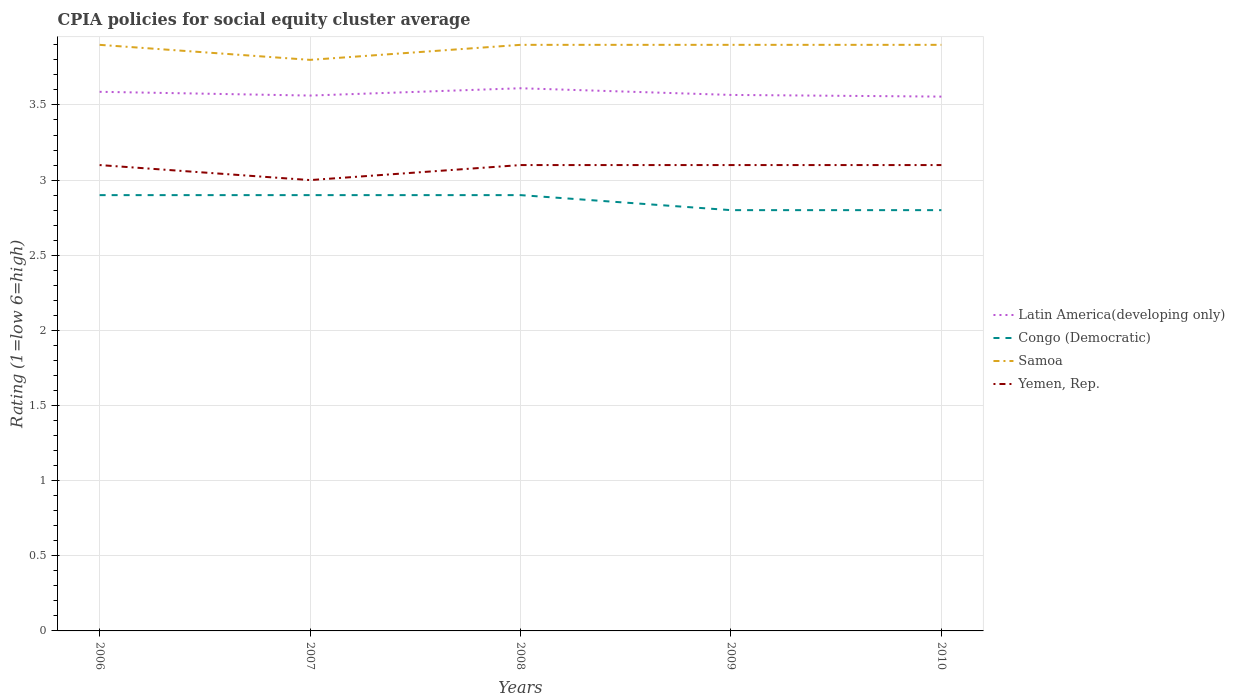How many different coloured lines are there?
Offer a terse response. 4. Does the line corresponding to Yemen, Rep. intersect with the line corresponding to Latin America(developing only)?
Provide a succinct answer. No. What is the total CPIA rating in Latin America(developing only) in the graph?
Ensure brevity in your answer.  -0.02. What is the difference between the highest and the second highest CPIA rating in Congo (Democratic)?
Provide a short and direct response. 0.1. What is the difference between the highest and the lowest CPIA rating in Latin America(developing only)?
Keep it short and to the point. 2. How many lines are there?
Offer a very short reply. 4. How many years are there in the graph?
Make the answer very short. 5. Are the values on the major ticks of Y-axis written in scientific E-notation?
Your answer should be very brief. No. Where does the legend appear in the graph?
Ensure brevity in your answer.  Center right. How are the legend labels stacked?
Keep it short and to the point. Vertical. What is the title of the graph?
Make the answer very short. CPIA policies for social equity cluster average. Does "Georgia" appear as one of the legend labels in the graph?
Your answer should be compact. No. What is the label or title of the X-axis?
Offer a very short reply. Years. What is the Rating (1=low 6=high) of Latin America(developing only) in 2006?
Provide a succinct answer. 3.59. What is the Rating (1=low 6=high) of Congo (Democratic) in 2006?
Provide a short and direct response. 2.9. What is the Rating (1=low 6=high) in Samoa in 2006?
Keep it short and to the point. 3.9. What is the Rating (1=low 6=high) of Yemen, Rep. in 2006?
Your answer should be very brief. 3.1. What is the Rating (1=low 6=high) of Latin America(developing only) in 2007?
Provide a short and direct response. 3.56. What is the Rating (1=low 6=high) of Congo (Democratic) in 2007?
Your answer should be compact. 2.9. What is the Rating (1=low 6=high) in Yemen, Rep. in 2007?
Your answer should be compact. 3. What is the Rating (1=low 6=high) of Latin America(developing only) in 2008?
Your answer should be very brief. 3.61. What is the Rating (1=low 6=high) in Latin America(developing only) in 2009?
Give a very brief answer. 3.57. What is the Rating (1=low 6=high) in Congo (Democratic) in 2009?
Give a very brief answer. 2.8. What is the Rating (1=low 6=high) in Yemen, Rep. in 2009?
Keep it short and to the point. 3.1. What is the Rating (1=low 6=high) of Latin America(developing only) in 2010?
Offer a very short reply. 3.56. What is the Rating (1=low 6=high) in Congo (Democratic) in 2010?
Give a very brief answer. 2.8. What is the Rating (1=low 6=high) in Samoa in 2010?
Your answer should be very brief. 3.9. Across all years, what is the maximum Rating (1=low 6=high) of Latin America(developing only)?
Provide a short and direct response. 3.61. Across all years, what is the maximum Rating (1=low 6=high) of Yemen, Rep.?
Your answer should be compact. 3.1. Across all years, what is the minimum Rating (1=low 6=high) in Latin America(developing only)?
Offer a very short reply. 3.56. Across all years, what is the minimum Rating (1=low 6=high) in Congo (Democratic)?
Your response must be concise. 2.8. Across all years, what is the minimum Rating (1=low 6=high) in Samoa?
Provide a short and direct response. 3.8. What is the total Rating (1=low 6=high) of Latin America(developing only) in the graph?
Make the answer very short. 17.88. What is the total Rating (1=low 6=high) of Congo (Democratic) in the graph?
Your answer should be compact. 14.3. What is the total Rating (1=low 6=high) in Samoa in the graph?
Provide a succinct answer. 19.4. What is the difference between the Rating (1=low 6=high) of Latin America(developing only) in 2006 and that in 2007?
Offer a very short reply. 0.03. What is the difference between the Rating (1=low 6=high) of Yemen, Rep. in 2006 and that in 2007?
Offer a terse response. 0.1. What is the difference between the Rating (1=low 6=high) in Latin America(developing only) in 2006 and that in 2008?
Your answer should be very brief. -0.02. What is the difference between the Rating (1=low 6=high) in Congo (Democratic) in 2006 and that in 2008?
Keep it short and to the point. 0. What is the difference between the Rating (1=low 6=high) in Samoa in 2006 and that in 2008?
Your response must be concise. 0. What is the difference between the Rating (1=low 6=high) in Yemen, Rep. in 2006 and that in 2008?
Ensure brevity in your answer.  0. What is the difference between the Rating (1=low 6=high) of Latin America(developing only) in 2006 and that in 2009?
Your answer should be very brief. 0.02. What is the difference between the Rating (1=low 6=high) in Latin America(developing only) in 2006 and that in 2010?
Make the answer very short. 0.03. What is the difference between the Rating (1=low 6=high) in Congo (Democratic) in 2006 and that in 2010?
Offer a very short reply. 0.1. What is the difference between the Rating (1=low 6=high) in Yemen, Rep. in 2006 and that in 2010?
Your answer should be very brief. 0. What is the difference between the Rating (1=low 6=high) of Latin America(developing only) in 2007 and that in 2008?
Provide a succinct answer. -0.05. What is the difference between the Rating (1=low 6=high) in Yemen, Rep. in 2007 and that in 2008?
Keep it short and to the point. -0.1. What is the difference between the Rating (1=low 6=high) in Latin America(developing only) in 2007 and that in 2009?
Offer a terse response. -0. What is the difference between the Rating (1=low 6=high) in Yemen, Rep. in 2007 and that in 2009?
Make the answer very short. -0.1. What is the difference between the Rating (1=low 6=high) of Latin America(developing only) in 2007 and that in 2010?
Provide a short and direct response. 0.01. What is the difference between the Rating (1=low 6=high) in Congo (Democratic) in 2007 and that in 2010?
Make the answer very short. 0.1. What is the difference between the Rating (1=low 6=high) in Latin America(developing only) in 2008 and that in 2009?
Make the answer very short. 0.04. What is the difference between the Rating (1=low 6=high) in Samoa in 2008 and that in 2009?
Provide a succinct answer. 0. What is the difference between the Rating (1=low 6=high) in Yemen, Rep. in 2008 and that in 2009?
Keep it short and to the point. 0. What is the difference between the Rating (1=low 6=high) in Latin America(developing only) in 2008 and that in 2010?
Keep it short and to the point. 0.06. What is the difference between the Rating (1=low 6=high) of Congo (Democratic) in 2008 and that in 2010?
Your answer should be very brief. 0.1. What is the difference between the Rating (1=low 6=high) of Yemen, Rep. in 2008 and that in 2010?
Offer a very short reply. 0. What is the difference between the Rating (1=low 6=high) of Latin America(developing only) in 2009 and that in 2010?
Offer a terse response. 0.01. What is the difference between the Rating (1=low 6=high) in Latin America(developing only) in 2006 and the Rating (1=low 6=high) in Congo (Democratic) in 2007?
Your response must be concise. 0.69. What is the difference between the Rating (1=low 6=high) in Latin America(developing only) in 2006 and the Rating (1=low 6=high) in Samoa in 2007?
Your answer should be very brief. -0.21. What is the difference between the Rating (1=low 6=high) in Latin America(developing only) in 2006 and the Rating (1=low 6=high) in Yemen, Rep. in 2007?
Make the answer very short. 0.59. What is the difference between the Rating (1=low 6=high) of Congo (Democratic) in 2006 and the Rating (1=low 6=high) of Samoa in 2007?
Provide a short and direct response. -0.9. What is the difference between the Rating (1=low 6=high) of Latin America(developing only) in 2006 and the Rating (1=low 6=high) of Congo (Democratic) in 2008?
Provide a short and direct response. 0.69. What is the difference between the Rating (1=low 6=high) of Latin America(developing only) in 2006 and the Rating (1=low 6=high) of Samoa in 2008?
Provide a succinct answer. -0.31. What is the difference between the Rating (1=low 6=high) of Latin America(developing only) in 2006 and the Rating (1=low 6=high) of Yemen, Rep. in 2008?
Ensure brevity in your answer.  0.49. What is the difference between the Rating (1=low 6=high) of Congo (Democratic) in 2006 and the Rating (1=low 6=high) of Samoa in 2008?
Provide a succinct answer. -1. What is the difference between the Rating (1=low 6=high) in Congo (Democratic) in 2006 and the Rating (1=low 6=high) in Yemen, Rep. in 2008?
Provide a short and direct response. -0.2. What is the difference between the Rating (1=low 6=high) in Latin America(developing only) in 2006 and the Rating (1=low 6=high) in Congo (Democratic) in 2009?
Provide a succinct answer. 0.79. What is the difference between the Rating (1=low 6=high) in Latin America(developing only) in 2006 and the Rating (1=low 6=high) in Samoa in 2009?
Your response must be concise. -0.31. What is the difference between the Rating (1=low 6=high) of Latin America(developing only) in 2006 and the Rating (1=low 6=high) of Yemen, Rep. in 2009?
Make the answer very short. 0.49. What is the difference between the Rating (1=low 6=high) of Congo (Democratic) in 2006 and the Rating (1=low 6=high) of Samoa in 2009?
Keep it short and to the point. -1. What is the difference between the Rating (1=low 6=high) in Congo (Democratic) in 2006 and the Rating (1=low 6=high) in Yemen, Rep. in 2009?
Offer a very short reply. -0.2. What is the difference between the Rating (1=low 6=high) in Latin America(developing only) in 2006 and the Rating (1=low 6=high) in Congo (Democratic) in 2010?
Keep it short and to the point. 0.79. What is the difference between the Rating (1=low 6=high) of Latin America(developing only) in 2006 and the Rating (1=low 6=high) of Samoa in 2010?
Provide a short and direct response. -0.31. What is the difference between the Rating (1=low 6=high) in Latin America(developing only) in 2006 and the Rating (1=low 6=high) in Yemen, Rep. in 2010?
Keep it short and to the point. 0.49. What is the difference between the Rating (1=low 6=high) of Congo (Democratic) in 2006 and the Rating (1=low 6=high) of Samoa in 2010?
Provide a short and direct response. -1. What is the difference between the Rating (1=low 6=high) of Latin America(developing only) in 2007 and the Rating (1=low 6=high) of Congo (Democratic) in 2008?
Give a very brief answer. 0.66. What is the difference between the Rating (1=low 6=high) of Latin America(developing only) in 2007 and the Rating (1=low 6=high) of Samoa in 2008?
Provide a succinct answer. -0.34. What is the difference between the Rating (1=low 6=high) in Latin America(developing only) in 2007 and the Rating (1=low 6=high) in Yemen, Rep. in 2008?
Provide a short and direct response. 0.46. What is the difference between the Rating (1=low 6=high) of Congo (Democratic) in 2007 and the Rating (1=low 6=high) of Samoa in 2008?
Keep it short and to the point. -1. What is the difference between the Rating (1=low 6=high) of Congo (Democratic) in 2007 and the Rating (1=low 6=high) of Yemen, Rep. in 2008?
Provide a succinct answer. -0.2. What is the difference between the Rating (1=low 6=high) of Latin America(developing only) in 2007 and the Rating (1=low 6=high) of Congo (Democratic) in 2009?
Provide a succinct answer. 0.76. What is the difference between the Rating (1=low 6=high) in Latin America(developing only) in 2007 and the Rating (1=low 6=high) in Samoa in 2009?
Your answer should be compact. -0.34. What is the difference between the Rating (1=low 6=high) of Latin America(developing only) in 2007 and the Rating (1=low 6=high) of Yemen, Rep. in 2009?
Ensure brevity in your answer.  0.46. What is the difference between the Rating (1=low 6=high) in Latin America(developing only) in 2007 and the Rating (1=low 6=high) in Congo (Democratic) in 2010?
Give a very brief answer. 0.76. What is the difference between the Rating (1=low 6=high) in Latin America(developing only) in 2007 and the Rating (1=low 6=high) in Samoa in 2010?
Provide a succinct answer. -0.34. What is the difference between the Rating (1=low 6=high) in Latin America(developing only) in 2007 and the Rating (1=low 6=high) in Yemen, Rep. in 2010?
Your response must be concise. 0.46. What is the difference between the Rating (1=low 6=high) of Congo (Democratic) in 2007 and the Rating (1=low 6=high) of Samoa in 2010?
Give a very brief answer. -1. What is the difference between the Rating (1=low 6=high) in Congo (Democratic) in 2007 and the Rating (1=low 6=high) in Yemen, Rep. in 2010?
Offer a terse response. -0.2. What is the difference between the Rating (1=low 6=high) of Samoa in 2007 and the Rating (1=low 6=high) of Yemen, Rep. in 2010?
Your answer should be compact. 0.7. What is the difference between the Rating (1=low 6=high) in Latin America(developing only) in 2008 and the Rating (1=low 6=high) in Congo (Democratic) in 2009?
Your answer should be compact. 0.81. What is the difference between the Rating (1=low 6=high) of Latin America(developing only) in 2008 and the Rating (1=low 6=high) of Samoa in 2009?
Provide a succinct answer. -0.29. What is the difference between the Rating (1=low 6=high) of Latin America(developing only) in 2008 and the Rating (1=low 6=high) of Yemen, Rep. in 2009?
Offer a very short reply. 0.51. What is the difference between the Rating (1=low 6=high) of Congo (Democratic) in 2008 and the Rating (1=low 6=high) of Samoa in 2009?
Keep it short and to the point. -1. What is the difference between the Rating (1=low 6=high) of Congo (Democratic) in 2008 and the Rating (1=low 6=high) of Yemen, Rep. in 2009?
Make the answer very short. -0.2. What is the difference between the Rating (1=low 6=high) of Latin America(developing only) in 2008 and the Rating (1=low 6=high) of Congo (Democratic) in 2010?
Provide a succinct answer. 0.81. What is the difference between the Rating (1=low 6=high) of Latin America(developing only) in 2008 and the Rating (1=low 6=high) of Samoa in 2010?
Offer a very short reply. -0.29. What is the difference between the Rating (1=low 6=high) in Latin America(developing only) in 2008 and the Rating (1=low 6=high) in Yemen, Rep. in 2010?
Make the answer very short. 0.51. What is the difference between the Rating (1=low 6=high) of Congo (Democratic) in 2008 and the Rating (1=low 6=high) of Samoa in 2010?
Your response must be concise. -1. What is the difference between the Rating (1=low 6=high) of Congo (Democratic) in 2008 and the Rating (1=low 6=high) of Yemen, Rep. in 2010?
Your answer should be compact. -0.2. What is the difference between the Rating (1=low 6=high) of Samoa in 2008 and the Rating (1=low 6=high) of Yemen, Rep. in 2010?
Your answer should be compact. 0.8. What is the difference between the Rating (1=low 6=high) in Latin America(developing only) in 2009 and the Rating (1=low 6=high) in Congo (Democratic) in 2010?
Ensure brevity in your answer.  0.77. What is the difference between the Rating (1=low 6=high) of Latin America(developing only) in 2009 and the Rating (1=low 6=high) of Yemen, Rep. in 2010?
Give a very brief answer. 0.47. What is the difference between the Rating (1=low 6=high) of Congo (Democratic) in 2009 and the Rating (1=low 6=high) of Samoa in 2010?
Your answer should be compact. -1.1. What is the difference between the Rating (1=low 6=high) in Samoa in 2009 and the Rating (1=low 6=high) in Yemen, Rep. in 2010?
Make the answer very short. 0.8. What is the average Rating (1=low 6=high) of Latin America(developing only) per year?
Keep it short and to the point. 3.58. What is the average Rating (1=low 6=high) of Congo (Democratic) per year?
Your answer should be compact. 2.86. What is the average Rating (1=low 6=high) of Samoa per year?
Your answer should be very brief. 3.88. What is the average Rating (1=low 6=high) of Yemen, Rep. per year?
Your answer should be compact. 3.08. In the year 2006, what is the difference between the Rating (1=low 6=high) of Latin America(developing only) and Rating (1=low 6=high) of Congo (Democratic)?
Your answer should be compact. 0.69. In the year 2006, what is the difference between the Rating (1=low 6=high) of Latin America(developing only) and Rating (1=low 6=high) of Samoa?
Keep it short and to the point. -0.31. In the year 2006, what is the difference between the Rating (1=low 6=high) in Latin America(developing only) and Rating (1=low 6=high) in Yemen, Rep.?
Your answer should be very brief. 0.49. In the year 2006, what is the difference between the Rating (1=low 6=high) of Congo (Democratic) and Rating (1=low 6=high) of Samoa?
Your response must be concise. -1. In the year 2006, what is the difference between the Rating (1=low 6=high) in Congo (Democratic) and Rating (1=low 6=high) in Yemen, Rep.?
Keep it short and to the point. -0.2. In the year 2006, what is the difference between the Rating (1=low 6=high) of Samoa and Rating (1=low 6=high) of Yemen, Rep.?
Provide a short and direct response. 0.8. In the year 2007, what is the difference between the Rating (1=low 6=high) in Latin America(developing only) and Rating (1=low 6=high) in Congo (Democratic)?
Offer a terse response. 0.66. In the year 2007, what is the difference between the Rating (1=low 6=high) in Latin America(developing only) and Rating (1=low 6=high) in Samoa?
Your answer should be compact. -0.24. In the year 2007, what is the difference between the Rating (1=low 6=high) in Latin America(developing only) and Rating (1=low 6=high) in Yemen, Rep.?
Your answer should be very brief. 0.56. In the year 2007, what is the difference between the Rating (1=low 6=high) in Congo (Democratic) and Rating (1=low 6=high) in Samoa?
Offer a terse response. -0.9. In the year 2007, what is the difference between the Rating (1=low 6=high) of Congo (Democratic) and Rating (1=low 6=high) of Yemen, Rep.?
Offer a very short reply. -0.1. In the year 2008, what is the difference between the Rating (1=low 6=high) of Latin America(developing only) and Rating (1=low 6=high) of Congo (Democratic)?
Your response must be concise. 0.71. In the year 2008, what is the difference between the Rating (1=low 6=high) of Latin America(developing only) and Rating (1=low 6=high) of Samoa?
Offer a terse response. -0.29. In the year 2008, what is the difference between the Rating (1=low 6=high) of Latin America(developing only) and Rating (1=low 6=high) of Yemen, Rep.?
Ensure brevity in your answer.  0.51. In the year 2008, what is the difference between the Rating (1=low 6=high) of Congo (Democratic) and Rating (1=low 6=high) of Yemen, Rep.?
Keep it short and to the point. -0.2. In the year 2008, what is the difference between the Rating (1=low 6=high) in Samoa and Rating (1=low 6=high) in Yemen, Rep.?
Provide a succinct answer. 0.8. In the year 2009, what is the difference between the Rating (1=low 6=high) in Latin America(developing only) and Rating (1=low 6=high) in Congo (Democratic)?
Your answer should be compact. 0.77. In the year 2009, what is the difference between the Rating (1=low 6=high) of Latin America(developing only) and Rating (1=low 6=high) of Samoa?
Offer a terse response. -0.33. In the year 2009, what is the difference between the Rating (1=low 6=high) of Latin America(developing only) and Rating (1=low 6=high) of Yemen, Rep.?
Offer a very short reply. 0.47. In the year 2009, what is the difference between the Rating (1=low 6=high) of Congo (Democratic) and Rating (1=low 6=high) of Yemen, Rep.?
Your answer should be compact. -0.3. In the year 2009, what is the difference between the Rating (1=low 6=high) of Samoa and Rating (1=low 6=high) of Yemen, Rep.?
Provide a short and direct response. 0.8. In the year 2010, what is the difference between the Rating (1=low 6=high) of Latin America(developing only) and Rating (1=low 6=high) of Congo (Democratic)?
Provide a short and direct response. 0.76. In the year 2010, what is the difference between the Rating (1=low 6=high) in Latin America(developing only) and Rating (1=low 6=high) in Samoa?
Your answer should be compact. -0.34. In the year 2010, what is the difference between the Rating (1=low 6=high) in Latin America(developing only) and Rating (1=low 6=high) in Yemen, Rep.?
Provide a succinct answer. 0.46. In the year 2010, what is the difference between the Rating (1=low 6=high) in Samoa and Rating (1=low 6=high) in Yemen, Rep.?
Offer a very short reply. 0.8. What is the ratio of the Rating (1=low 6=high) in Latin America(developing only) in 2006 to that in 2007?
Offer a very short reply. 1.01. What is the ratio of the Rating (1=low 6=high) in Congo (Democratic) in 2006 to that in 2007?
Keep it short and to the point. 1. What is the ratio of the Rating (1=low 6=high) of Samoa in 2006 to that in 2007?
Your answer should be very brief. 1.03. What is the ratio of the Rating (1=low 6=high) in Yemen, Rep. in 2006 to that in 2007?
Provide a succinct answer. 1.03. What is the ratio of the Rating (1=low 6=high) of Latin America(developing only) in 2006 to that in 2008?
Give a very brief answer. 0.99. What is the ratio of the Rating (1=low 6=high) of Latin America(developing only) in 2006 to that in 2009?
Your response must be concise. 1.01. What is the ratio of the Rating (1=low 6=high) of Congo (Democratic) in 2006 to that in 2009?
Offer a terse response. 1.04. What is the ratio of the Rating (1=low 6=high) of Samoa in 2006 to that in 2009?
Your answer should be compact. 1. What is the ratio of the Rating (1=low 6=high) in Yemen, Rep. in 2006 to that in 2009?
Make the answer very short. 1. What is the ratio of the Rating (1=low 6=high) in Latin America(developing only) in 2006 to that in 2010?
Your answer should be very brief. 1.01. What is the ratio of the Rating (1=low 6=high) of Congo (Democratic) in 2006 to that in 2010?
Your answer should be very brief. 1.04. What is the ratio of the Rating (1=low 6=high) of Samoa in 2006 to that in 2010?
Provide a succinct answer. 1. What is the ratio of the Rating (1=low 6=high) in Yemen, Rep. in 2006 to that in 2010?
Make the answer very short. 1. What is the ratio of the Rating (1=low 6=high) of Latin America(developing only) in 2007 to that in 2008?
Offer a terse response. 0.99. What is the ratio of the Rating (1=low 6=high) in Congo (Democratic) in 2007 to that in 2008?
Your answer should be compact. 1. What is the ratio of the Rating (1=low 6=high) of Samoa in 2007 to that in 2008?
Your answer should be compact. 0.97. What is the ratio of the Rating (1=low 6=high) in Latin America(developing only) in 2007 to that in 2009?
Offer a terse response. 1. What is the ratio of the Rating (1=low 6=high) of Congo (Democratic) in 2007 to that in 2009?
Provide a succinct answer. 1.04. What is the ratio of the Rating (1=low 6=high) of Samoa in 2007 to that in 2009?
Offer a terse response. 0.97. What is the ratio of the Rating (1=low 6=high) in Latin America(developing only) in 2007 to that in 2010?
Provide a succinct answer. 1. What is the ratio of the Rating (1=low 6=high) in Congo (Democratic) in 2007 to that in 2010?
Make the answer very short. 1.04. What is the ratio of the Rating (1=low 6=high) of Samoa in 2007 to that in 2010?
Your answer should be compact. 0.97. What is the ratio of the Rating (1=low 6=high) in Yemen, Rep. in 2007 to that in 2010?
Ensure brevity in your answer.  0.97. What is the ratio of the Rating (1=low 6=high) of Latin America(developing only) in 2008 to that in 2009?
Keep it short and to the point. 1.01. What is the ratio of the Rating (1=low 6=high) in Congo (Democratic) in 2008 to that in 2009?
Your response must be concise. 1.04. What is the ratio of the Rating (1=low 6=high) of Samoa in 2008 to that in 2009?
Ensure brevity in your answer.  1. What is the ratio of the Rating (1=low 6=high) of Yemen, Rep. in 2008 to that in 2009?
Ensure brevity in your answer.  1. What is the ratio of the Rating (1=low 6=high) of Latin America(developing only) in 2008 to that in 2010?
Provide a succinct answer. 1.02. What is the ratio of the Rating (1=low 6=high) in Congo (Democratic) in 2008 to that in 2010?
Your answer should be very brief. 1.04. What is the ratio of the Rating (1=low 6=high) of Yemen, Rep. in 2008 to that in 2010?
Keep it short and to the point. 1. What is the ratio of the Rating (1=low 6=high) in Latin America(developing only) in 2009 to that in 2010?
Ensure brevity in your answer.  1. What is the ratio of the Rating (1=low 6=high) in Samoa in 2009 to that in 2010?
Provide a succinct answer. 1. What is the difference between the highest and the second highest Rating (1=low 6=high) of Latin America(developing only)?
Offer a very short reply. 0.02. What is the difference between the highest and the second highest Rating (1=low 6=high) of Samoa?
Ensure brevity in your answer.  0. What is the difference between the highest and the second highest Rating (1=low 6=high) in Yemen, Rep.?
Your answer should be compact. 0. What is the difference between the highest and the lowest Rating (1=low 6=high) in Latin America(developing only)?
Your response must be concise. 0.06. What is the difference between the highest and the lowest Rating (1=low 6=high) of Samoa?
Provide a short and direct response. 0.1. What is the difference between the highest and the lowest Rating (1=low 6=high) of Yemen, Rep.?
Provide a short and direct response. 0.1. 